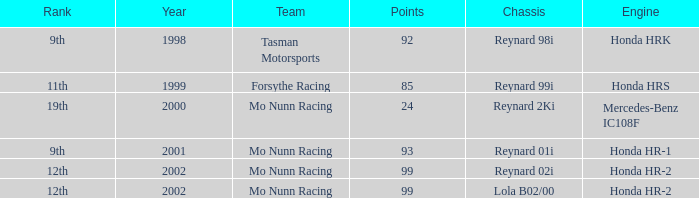What is the rank of the reynard 2ki chassis before 2002? 19th. 